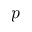<formula> <loc_0><loc_0><loc_500><loc_500>p</formula> 